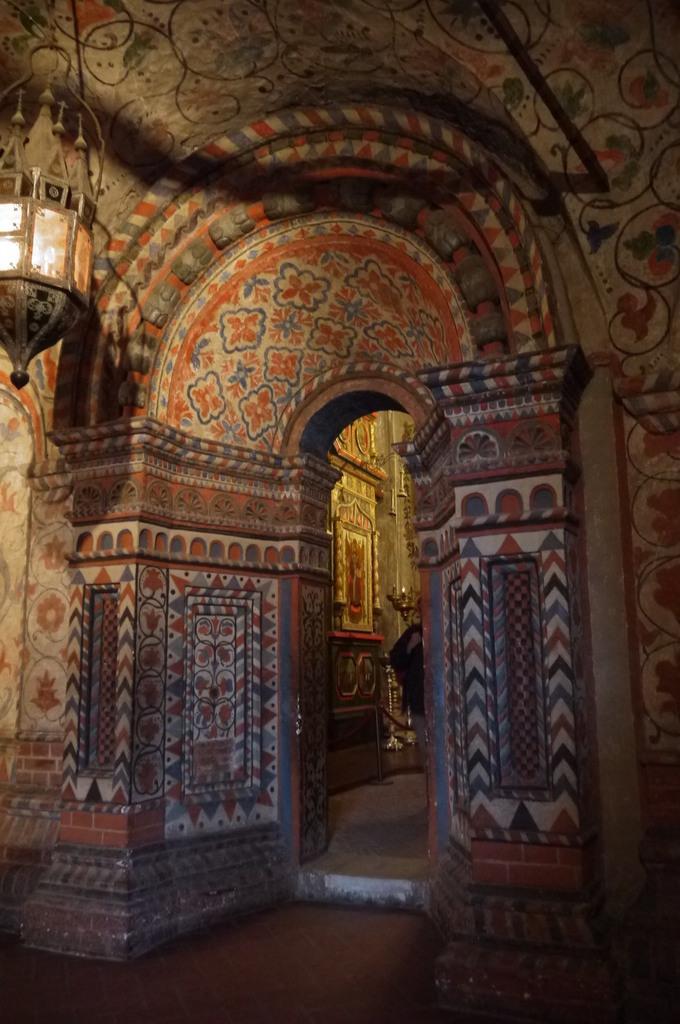Please provide a concise description of this image. In this image there is floor at the bottom. There is a light on the left corner. There are pillars with the roof in the foreground. There is a person, it looks like a wall with design in the background. 